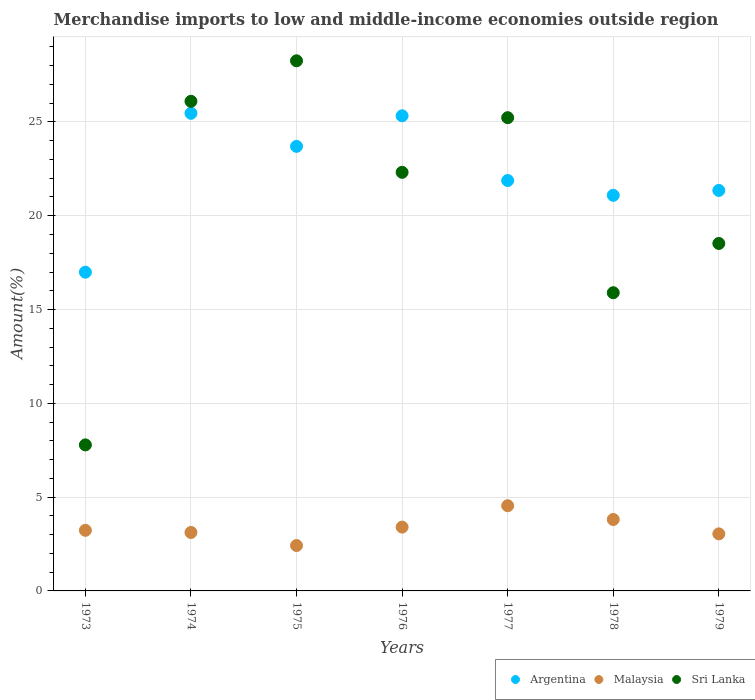How many different coloured dotlines are there?
Give a very brief answer. 3. Is the number of dotlines equal to the number of legend labels?
Offer a very short reply. Yes. What is the percentage of amount earned from merchandise imports in Malaysia in 1978?
Your answer should be very brief. 3.81. Across all years, what is the maximum percentage of amount earned from merchandise imports in Argentina?
Give a very brief answer. 25.46. Across all years, what is the minimum percentage of amount earned from merchandise imports in Sri Lanka?
Offer a terse response. 7.78. In which year was the percentage of amount earned from merchandise imports in Argentina maximum?
Provide a succinct answer. 1974. In which year was the percentage of amount earned from merchandise imports in Sri Lanka minimum?
Keep it short and to the point. 1973. What is the total percentage of amount earned from merchandise imports in Sri Lanka in the graph?
Give a very brief answer. 144.1. What is the difference between the percentage of amount earned from merchandise imports in Sri Lanka in 1974 and that in 1976?
Ensure brevity in your answer.  3.79. What is the difference between the percentage of amount earned from merchandise imports in Argentina in 1975 and the percentage of amount earned from merchandise imports in Sri Lanka in 1974?
Provide a short and direct response. -2.4. What is the average percentage of amount earned from merchandise imports in Malaysia per year?
Give a very brief answer. 3.37. In the year 1976, what is the difference between the percentage of amount earned from merchandise imports in Sri Lanka and percentage of amount earned from merchandise imports in Malaysia?
Provide a short and direct response. 18.91. What is the ratio of the percentage of amount earned from merchandise imports in Sri Lanka in 1978 to that in 1979?
Your answer should be compact. 0.86. Is the difference between the percentage of amount earned from merchandise imports in Sri Lanka in 1974 and 1978 greater than the difference between the percentage of amount earned from merchandise imports in Malaysia in 1974 and 1978?
Offer a terse response. Yes. What is the difference between the highest and the second highest percentage of amount earned from merchandise imports in Sri Lanka?
Give a very brief answer. 2.16. What is the difference between the highest and the lowest percentage of amount earned from merchandise imports in Argentina?
Offer a very short reply. 8.47. What is the difference between two consecutive major ticks on the Y-axis?
Make the answer very short. 5. Where does the legend appear in the graph?
Your answer should be compact. Bottom right. What is the title of the graph?
Ensure brevity in your answer.  Merchandise imports to low and middle-income economies outside region. Does "Cambodia" appear as one of the legend labels in the graph?
Provide a succinct answer. No. What is the label or title of the Y-axis?
Your response must be concise. Amount(%). What is the Amount(%) of Argentina in 1973?
Provide a short and direct response. 16.99. What is the Amount(%) in Malaysia in 1973?
Provide a succinct answer. 3.23. What is the Amount(%) of Sri Lanka in 1973?
Make the answer very short. 7.78. What is the Amount(%) in Argentina in 1974?
Provide a succinct answer. 25.46. What is the Amount(%) of Malaysia in 1974?
Offer a very short reply. 3.12. What is the Amount(%) of Sri Lanka in 1974?
Give a very brief answer. 26.1. What is the Amount(%) of Argentina in 1975?
Your response must be concise. 23.7. What is the Amount(%) in Malaysia in 1975?
Offer a very short reply. 2.42. What is the Amount(%) in Sri Lanka in 1975?
Your response must be concise. 28.26. What is the Amount(%) of Argentina in 1976?
Give a very brief answer. 25.33. What is the Amount(%) in Malaysia in 1976?
Give a very brief answer. 3.4. What is the Amount(%) of Sri Lanka in 1976?
Your response must be concise. 22.31. What is the Amount(%) in Argentina in 1977?
Your answer should be very brief. 21.88. What is the Amount(%) of Malaysia in 1977?
Offer a very short reply. 4.54. What is the Amount(%) in Sri Lanka in 1977?
Offer a terse response. 25.23. What is the Amount(%) of Argentina in 1978?
Your answer should be compact. 21.09. What is the Amount(%) of Malaysia in 1978?
Provide a short and direct response. 3.81. What is the Amount(%) in Sri Lanka in 1978?
Give a very brief answer. 15.9. What is the Amount(%) of Argentina in 1979?
Offer a very short reply. 21.35. What is the Amount(%) in Malaysia in 1979?
Give a very brief answer. 3.04. What is the Amount(%) of Sri Lanka in 1979?
Provide a short and direct response. 18.52. Across all years, what is the maximum Amount(%) of Argentina?
Provide a succinct answer. 25.46. Across all years, what is the maximum Amount(%) of Malaysia?
Make the answer very short. 4.54. Across all years, what is the maximum Amount(%) of Sri Lanka?
Offer a terse response. 28.26. Across all years, what is the minimum Amount(%) of Argentina?
Give a very brief answer. 16.99. Across all years, what is the minimum Amount(%) in Malaysia?
Offer a very short reply. 2.42. Across all years, what is the minimum Amount(%) of Sri Lanka?
Give a very brief answer. 7.78. What is the total Amount(%) in Argentina in the graph?
Offer a very short reply. 155.79. What is the total Amount(%) in Malaysia in the graph?
Your answer should be compact. 23.56. What is the total Amount(%) in Sri Lanka in the graph?
Make the answer very short. 144.1. What is the difference between the Amount(%) in Argentina in 1973 and that in 1974?
Your answer should be compact. -8.47. What is the difference between the Amount(%) in Malaysia in 1973 and that in 1974?
Give a very brief answer. 0.11. What is the difference between the Amount(%) of Sri Lanka in 1973 and that in 1974?
Your answer should be very brief. -18.32. What is the difference between the Amount(%) in Argentina in 1973 and that in 1975?
Keep it short and to the point. -6.71. What is the difference between the Amount(%) in Malaysia in 1973 and that in 1975?
Keep it short and to the point. 0.81. What is the difference between the Amount(%) in Sri Lanka in 1973 and that in 1975?
Give a very brief answer. -20.47. What is the difference between the Amount(%) in Argentina in 1973 and that in 1976?
Offer a very short reply. -8.34. What is the difference between the Amount(%) of Malaysia in 1973 and that in 1976?
Your answer should be very brief. -0.17. What is the difference between the Amount(%) of Sri Lanka in 1973 and that in 1976?
Offer a very short reply. -14.53. What is the difference between the Amount(%) in Argentina in 1973 and that in 1977?
Offer a terse response. -4.89. What is the difference between the Amount(%) in Malaysia in 1973 and that in 1977?
Your answer should be very brief. -1.31. What is the difference between the Amount(%) of Sri Lanka in 1973 and that in 1977?
Make the answer very short. -17.44. What is the difference between the Amount(%) in Argentina in 1973 and that in 1978?
Your response must be concise. -4.1. What is the difference between the Amount(%) of Malaysia in 1973 and that in 1978?
Your answer should be very brief. -0.58. What is the difference between the Amount(%) of Sri Lanka in 1973 and that in 1978?
Give a very brief answer. -8.11. What is the difference between the Amount(%) in Argentina in 1973 and that in 1979?
Your answer should be compact. -4.36. What is the difference between the Amount(%) of Malaysia in 1973 and that in 1979?
Your answer should be compact. 0.19. What is the difference between the Amount(%) of Sri Lanka in 1973 and that in 1979?
Your response must be concise. -10.74. What is the difference between the Amount(%) of Argentina in 1974 and that in 1975?
Your answer should be compact. 1.76. What is the difference between the Amount(%) in Malaysia in 1974 and that in 1975?
Keep it short and to the point. 0.7. What is the difference between the Amount(%) in Sri Lanka in 1974 and that in 1975?
Your response must be concise. -2.16. What is the difference between the Amount(%) in Argentina in 1974 and that in 1976?
Your answer should be compact. 0.13. What is the difference between the Amount(%) in Malaysia in 1974 and that in 1976?
Your answer should be very brief. -0.29. What is the difference between the Amount(%) of Sri Lanka in 1974 and that in 1976?
Make the answer very short. 3.79. What is the difference between the Amount(%) of Argentina in 1974 and that in 1977?
Make the answer very short. 3.58. What is the difference between the Amount(%) of Malaysia in 1974 and that in 1977?
Offer a terse response. -1.43. What is the difference between the Amount(%) in Sri Lanka in 1974 and that in 1977?
Offer a very short reply. 0.87. What is the difference between the Amount(%) in Argentina in 1974 and that in 1978?
Keep it short and to the point. 4.37. What is the difference between the Amount(%) in Malaysia in 1974 and that in 1978?
Make the answer very short. -0.69. What is the difference between the Amount(%) of Sri Lanka in 1974 and that in 1978?
Offer a very short reply. 10.2. What is the difference between the Amount(%) in Argentina in 1974 and that in 1979?
Make the answer very short. 4.11. What is the difference between the Amount(%) of Malaysia in 1974 and that in 1979?
Provide a succinct answer. 0.07. What is the difference between the Amount(%) of Sri Lanka in 1974 and that in 1979?
Provide a succinct answer. 7.58. What is the difference between the Amount(%) in Argentina in 1975 and that in 1976?
Ensure brevity in your answer.  -1.63. What is the difference between the Amount(%) in Malaysia in 1975 and that in 1976?
Keep it short and to the point. -0.98. What is the difference between the Amount(%) of Sri Lanka in 1975 and that in 1976?
Keep it short and to the point. 5.94. What is the difference between the Amount(%) of Argentina in 1975 and that in 1977?
Provide a succinct answer. 1.82. What is the difference between the Amount(%) in Malaysia in 1975 and that in 1977?
Your answer should be very brief. -2.12. What is the difference between the Amount(%) of Sri Lanka in 1975 and that in 1977?
Provide a short and direct response. 3.03. What is the difference between the Amount(%) in Argentina in 1975 and that in 1978?
Your answer should be very brief. 2.61. What is the difference between the Amount(%) in Malaysia in 1975 and that in 1978?
Ensure brevity in your answer.  -1.39. What is the difference between the Amount(%) in Sri Lanka in 1975 and that in 1978?
Your answer should be very brief. 12.36. What is the difference between the Amount(%) of Argentina in 1975 and that in 1979?
Give a very brief answer. 2.35. What is the difference between the Amount(%) of Malaysia in 1975 and that in 1979?
Your answer should be compact. -0.62. What is the difference between the Amount(%) in Sri Lanka in 1975 and that in 1979?
Make the answer very short. 9.74. What is the difference between the Amount(%) of Argentina in 1976 and that in 1977?
Provide a succinct answer. 3.45. What is the difference between the Amount(%) in Malaysia in 1976 and that in 1977?
Offer a terse response. -1.14. What is the difference between the Amount(%) in Sri Lanka in 1976 and that in 1977?
Offer a very short reply. -2.91. What is the difference between the Amount(%) of Argentina in 1976 and that in 1978?
Your response must be concise. 4.24. What is the difference between the Amount(%) in Malaysia in 1976 and that in 1978?
Ensure brevity in your answer.  -0.41. What is the difference between the Amount(%) of Sri Lanka in 1976 and that in 1978?
Your response must be concise. 6.42. What is the difference between the Amount(%) of Argentina in 1976 and that in 1979?
Ensure brevity in your answer.  3.98. What is the difference between the Amount(%) of Malaysia in 1976 and that in 1979?
Ensure brevity in your answer.  0.36. What is the difference between the Amount(%) in Sri Lanka in 1976 and that in 1979?
Your answer should be very brief. 3.79. What is the difference between the Amount(%) in Argentina in 1977 and that in 1978?
Keep it short and to the point. 0.79. What is the difference between the Amount(%) in Malaysia in 1977 and that in 1978?
Ensure brevity in your answer.  0.73. What is the difference between the Amount(%) in Sri Lanka in 1977 and that in 1978?
Make the answer very short. 9.33. What is the difference between the Amount(%) in Argentina in 1977 and that in 1979?
Provide a succinct answer. 0.53. What is the difference between the Amount(%) in Malaysia in 1977 and that in 1979?
Your answer should be compact. 1.5. What is the difference between the Amount(%) of Sri Lanka in 1977 and that in 1979?
Your response must be concise. 6.71. What is the difference between the Amount(%) of Argentina in 1978 and that in 1979?
Offer a very short reply. -0.26. What is the difference between the Amount(%) in Malaysia in 1978 and that in 1979?
Your answer should be very brief. 0.77. What is the difference between the Amount(%) in Sri Lanka in 1978 and that in 1979?
Your answer should be compact. -2.63. What is the difference between the Amount(%) of Argentina in 1973 and the Amount(%) of Malaysia in 1974?
Make the answer very short. 13.87. What is the difference between the Amount(%) of Argentina in 1973 and the Amount(%) of Sri Lanka in 1974?
Your answer should be compact. -9.11. What is the difference between the Amount(%) in Malaysia in 1973 and the Amount(%) in Sri Lanka in 1974?
Your response must be concise. -22.87. What is the difference between the Amount(%) of Argentina in 1973 and the Amount(%) of Malaysia in 1975?
Offer a very short reply. 14.57. What is the difference between the Amount(%) in Argentina in 1973 and the Amount(%) in Sri Lanka in 1975?
Make the answer very short. -11.27. What is the difference between the Amount(%) in Malaysia in 1973 and the Amount(%) in Sri Lanka in 1975?
Ensure brevity in your answer.  -25.03. What is the difference between the Amount(%) in Argentina in 1973 and the Amount(%) in Malaysia in 1976?
Provide a succinct answer. 13.59. What is the difference between the Amount(%) of Argentina in 1973 and the Amount(%) of Sri Lanka in 1976?
Offer a very short reply. -5.32. What is the difference between the Amount(%) of Malaysia in 1973 and the Amount(%) of Sri Lanka in 1976?
Your response must be concise. -19.08. What is the difference between the Amount(%) in Argentina in 1973 and the Amount(%) in Malaysia in 1977?
Provide a short and direct response. 12.45. What is the difference between the Amount(%) of Argentina in 1973 and the Amount(%) of Sri Lanka in 1977?
Your answer should be compact. -8.24. What is the difference between the Amount(%) in Malaysia in 1973 and the Amount(%) in Sri Lanka in 1977?
Offer a terse response. -22. What is the difference between the Amount(%) of Argentina in 1973 and the Amount(%) of Malaysia in 1978?
Keep it short and to the point. 13.18. What is the difference between the Amount(%) in Argentina in 1973 and the Amount(%) in Sri Lanka in 1978?
Your response must be concise. 1.09. What is the difference between the Amount(%) in Malaysia in 1973 and the Amount(%) in Sri Lanka in 1978?
Make the answer very short. -12.67. What is the difference between the Amount(%) in Argentina in 1973 and the Amount(%) in Malaysia in 1979?
Your answer should be compact. 13.95. What is the difference between the Amount(%) of Argentina in 1973 and the Amount(%) of Sri Lanka in 1979?
Your response must be concise. -1.53. What is the difference between the Amount(%) in Malaysia in 1973 and the Amount(%) in Sri Lanka in 1979?
Provide a short and direct response. -15.29. What is the difference between the Amount(%) of Argentina in 1974 and the Amount(%) of Malaysia in 1975?
Give a very brief answer. 23.04. What is the difference between the Amount(%) of Argentina in 1974 and the Amount(%) of Sri Lanka in 1975?
Keep it short and to the point. -2.8. What is the difference between the Amount(%) of Malaysia in 1974 and the Amount(%) of Sri Lanka in 1975?
Give a very brief answer. -25.14. What is the difference between the Amount(%) of Argentina in 1974 and the Amount(%) of Malaysia in 1976?
Your answer should be compact. 22.06. What is the difference between the Amount(%) of Argentina in 1974 and the Amount(%) of Sri Lanka in 1976?
Your response must be concise. 3.15. What is the difference between the Amount(%) of Malaysia in 1974 and the Amount(%) of Sri Lanka in 1976?
Offer a very short reply. -19.2. What is the difference between the Amount(%) in Argentina in 1974 and the Amount(%) in Malaysia in 1977?
Keep it short and to the point. 20.92. What is the difference between the Amount(%) in Argentina in 1974 and the Amount(%) in Sri Lanka in 1977?
Ensure brevity in your answer.  0.23. What is the difference between the Amount(%) in Malaysia in 1974 and the Amount(%) in Sri Lanka in 1977?
Provide a short and direct response. -22.11. What is the difference between the Amount(%) in Argentina in 1974 and the Amount(%) in Malaysia in 1978?
Keep it short and to the point. 21.65. What is the difference between the Amount(%) in Argentina in 1974 and the Amount(%) in Sri Lanka in 1978?
Offer a terse response. 9.56. What is the difference between the Amount(%) of Malaysia in 1974 and the Amount(%) of Sri Lanka in 1978?
Make the answer very short. -12.78. What is the difference between the Amount(%) of Argentina in 1974 and the Amount(%) of Malaysia in 1979?
Ensure brevity in your answer.  22.42. What is the difference between the Amount(%) of Argentina in 1974 and the Amount(%) of Sri Lanka in 1979?
Your answer should be very brief. 6.94. What is the difference between the Amount(%) in Malaysia in 1974 and the Amount(%) in Sri Lanka in 1979?
Your answer should be very brief. -15.41. What is the difference between the Amount(%) in Argentina in 1975 and the Amount(%) in Malaysia in 1976?
Offer a very short reply. 20.3. What is the difference between the Amount(%) of Argentina in 1975 and the Amount(%) of Sri Lanka in 1976?
Provide a short and direct response. 1.38. What is the difference between the Amount(%) in Malaysia in 1975 and the Amount(%) in Sri Lanka in 1976?
Provide a short and direct response. -19.89. What is the difference between the Amount(%) of Argentina in 1975 and the Amount(%) of Malaysia in 1977?
Give a very brief answer. 19.16. What is the difference between the Amount(%) in Argentina in 1975 and the Amount(%) in Sri Lanka in 1977?
Your answer should be compact. -1.53. What is the difference between the Amount(%) in Malaysia in 1975 and the Amount(%) in Sri Lanka in 1977?
Offer a very short reply. -22.81. What is the difference between the Amount(%) of Argentina in 1975 and the Amount(%) of Malaysia in 1978?
Your answer should be compact. 19.89. What is the difference between the Amount(%) of Argentina in 1975 and the Amount(%) of Sri Lanka in 1978?
Provide a succinct answer. 7.8. What is the difference between the Amount(%) in Malaysia in 1975 and the Amount(%) in Sri Lanka in 1978?
Provide a succinct answer. -13.48. What is the difference between the Amount(%) of Argentina in 1975 and the Amount(%) of Malaysia in 1979?
Your response must be concise. 20.66. What is the difference between the Amount(%) in Argentina in 1975 and the Amount(%) in Sri Lanka in 1979?
Give a very brief answer. 5.18. What is the difference between the Amount(%) of Malaysia in 1975 and the Amount(%) of Sri Lanka in 1979?
Keep it short and to the point. -16.1. What is the difference between the Amount(%) of Argentina in 1976 and the Amount(%) of Malaysia in 1977?
Provide a succinct answer. 20.79. What is the difference between the Amount(%) in Argentina in 1976 and the Amount(%) in Sri Lanka in 1977?
Offer a terse response. 0.1. What is the difference between the Amount(%) of Malaysia in 1976 and the Amount(%) of Sri Lanka in 1977?
Offer a very short reply. -21.82. What is the difference between the Amount(%) in Argentina in 1976 and the Amount(%) in Malaysia in 1978?
Give a very brief answer. 21.52. What is the difference between the Amount(%) in Argentina in 1976 and the Amount(%) in Sri Lanka in 1978?
Provide a succinct answer. 9.43. What is the difference between the Amount(%) in Malaysia in 1976 and the Amount(%) in Sri Lanka in 1978?
Offer a very short reply. -12.49. What is the difference between the Amount(%) in Argentina in 1976 and the Amount(%) in Malaysia in 1979?
Keep it short and to the point. 22.29. What is the difference between the Amount(%) in Argentina in 1976 and the Amount(%) in Sri Lanka in 1979?
Keep it short and to the point. 6.81. What is the difference between the Amount(%) in Malaysia in 1976 and the Amount(%) in Sri Lanka in 1979?
Provide a short and direct response. -15.12. What is the difference between the Amount(%) in Argentina in 1977 and the Amount(%) in Malaysia in 1978?
Keep it short and to the point. 18.07. What is the difference between the Amount(%) of Argentina in 1977 and the Amount(%) of Sri Lanka in 1978?
Offer a terse response. 5.98. What is the difference between the Amount(%) of Malaysia in 1977 and the Amount(%) of Sri Lanka in 1978?
Offer a very short reply. -11.35. What is the difference between the Amount(%) in Argentina in 1977 and the Amount(%) in Malaysia in 1979?
Provide a succinct answer. 18.83. What is the difference between the Amount(%) in Argentina in 1977 and the Amount(%) in Sri Lanka in 1979?
Your answer should be compact. 3.35. What is the difference between the Amount(%) in Malaysia in 1977 and the Amount(%) in Sri Lanka in 1979?
Provide a succinct answer. -13.98. What is the difference between the Amount(%) of Argentina in 1978 and the Amount(%) of Malaysia in 1979?
Your answer should be very brief. 18.05. What is the difference between the Amount(%) of Argentina in 1978 and the Amount(%) of Sri Lanka in 1979?
Your response must be concise. 2.57. What is the difference between the Amount(%) in Malaysia in 1978 and the Amount(%) in Sri Lanka in 1979?
Provide a short and direct response. -14.71. What is the average Amount(%) in Argentina per year?
Offer a very short reply. 22.26. What is the average Amount(%) in Malaysia per year?
Ensure brevity in your answer.  3.37. What is the average Amount(%) of Sri Lanka per year?
Give a very brief answer. 20.59. In the year 1973, what is the difference between the Amount(%) in Argentina and Amount(%) in Malaysia?
Offer a terse response. 13.76. In the year 1973, what is the difference between the Amount(%) of Argentina and Amount(%) of Sri Lanka?
Keep it short and to the point. 9.21. In the year 1973, what is the difference between the Amount(%) in Malaysia and Amount(%) in Sri Lanka?
Keep it short and to the point. -4.55. In the year 1974, what is the difference between the Amount(%) of Argentina and Amount(%) of Malaysia?
Ensure brevity in your answer.  22.34. In the year 1974, what is the difference between the Amount(%) in Argentina and Amount(%) in Sri Lanka?
Give a very brief answer. -0.64. In the year 1974, what is the difference between the Amount(%) in Malaysia and Amount(%) in Sri Lanka?
Your answer should be very brief. -22.98. In the year 1975, what is the difference between the Amount(%) of Argentina and Amount(%) of Malaysia?
Your answer should be compact. 21.28. In the year 1975, what is the difference between the Amount(%) in Argentina and Amount(%) in Sri Lanka?
Offer a terse response. -4.56. In the year 1975, what is the difference between the Amount(%) in Malaysia and Amount(%) in Sri Lanka?
Your answer should be compact. -25.84. In the year 1976, what is the difference between the Amount(%) in Argentina and Amount(%) in Malaysia?
Offer a very short reply. 21.93. In the year 1976, what is the difference between the Amount(%) of Argentina and Amount(%) of Sri Lanka?
Keep it short and to the point. 3.01. In the year 1976, what is the difference between the Amount(%) in Malaysia and Amount(%) in Sri Lanka?
Offer a very short reply. -18.91. In the year 1977, what is the difference between the Amount(%) in Argentina and Amount(%) in Malaysia?
Your answer should be very brief. 17.33. In the year 1977, what is the difference between the Amount(%) of Argentina and Amount(%) of Sri Lanka?
Offer a very short reply. -3.35. In the year 1977, what is the difference between the Amount(%) in Malaysia and Amount(%) in Sri Lanka?
Ensure brevity in your answer.  -20.69. In the year 1978, what is the difference between the Amount(%) in Argentina and Amount(%) in Malaysia?
Offer a very short reply. 17.28. In the year 1978, what is the difference between the Amount(%) of Argentina and Amount(%) of Sri Lanka?
Ensure brevity in your answer.  5.19. In the year 1978, what is the difference between the Amount(%) in Malaysia and Amount(%) in Sri Lanka?
Provide a succinct answer. -12.09. In the year 1979, what is the difference between the Amount(%) of Argentina and Amount(%) of Malaysia?
Your answer should be compact. 18.31. In the year 1979, what is the difference between the Amount(%) of Argentina and Amount(%) of Sri Lanka?
Ensure brevity in your answer.  2.83. In the year 1979, what is the difference between the Amount(%) of Malaysia and Amount(%) of Sri Lanka?
Give a very brief answer. -15.48. What is the ratio of the Amount(%) in Argentina in 1973 to that in 1974?
Provide a succinct answer. 0.67. What is the ratio of the Amount(%) in Malaysia in 1973 to that in 1974?
Keep it short and to the point. 1.04. What is the ratio of the Amount(%) in Sri Lanka in 1973 to that in 1974?
Ensure brevity in your answer.  0.3. What is the ratio of the Amount(%) of Argentina in 1973 to that in 1975?
Your answer should be very brief. 0.72. What is the ratio of the Amount(%) of Malaysia in 1973 to that in 1975?
Your answer should be compact. 1.33. What is the ratio of the Amount(%) in Sri Lanka in 1973 to that in 1975?
Your response must be concise. 0.28. What is the ratio of the Amount(%) in Argentina in 1973 to that in 1976?
Your answer should be very brief. 0.67. What is the ratio of the Amount(%) of Malaysia in 1973 to that in 1976?
Your response must be concise. 0.95. What is the ratio of the Amount(%) in Sri Lanka in 1973 to that in 1976?
Give a very brief answer. 0.35. What is the ratio of the Amount(%) of Argentina in 1973 to that in 1977?
Provide a succinct answer. 0.78. What is the ratio of the Amount(%) of Malaysia in 1973 to that in 1977?
Offer a terse response. 0.71. What is the ratio of the Amount(%) of Sri Lanka in 1973 to that in 1977?
Your answer should be very brief. 0.31. What is the ratio of the Amount(%) of Argentina in 1973 to that in 1978?
Your response must be concise. 0.81. What is the ratio of the Amount(%) in Malaysia in 1973 to that in 1978?
Your response must be concise. 0.85. What is the ratio of the Amount(%) in Sri Lanka in 1973 to that in 1978?
Your response must be concise. 0.49. What is the ratio of the Amount(%) in Argentina in 1973 to that in 1979?
Your answer should be compact. 0.8. What is the ratio of the Amount(%) of Malaysia in 1973 to that in 1979?
Give a very brief answer. 1.06. What is the ratio of the Amount(%) of Sri Lanka in 1973 to that in 1979?
Your response must be concise. 0.42. What is the ratio of the Amount(%) in Argentina in 1974 to that in 1975?
Make the answer very short. 1.07. What is the ratio of the Amount(%) in Malaysia in 1974 to that in 1975?
Your answer should be very brief. 1.29. What is the ratio of the Amount(%) in Sri Lanka in 1974 to that in 1975?
Provide a succinct answer. 0.92. What is the ratio of the Amount(%) in Malaysia in 1974 to that in 1976?
Provide a short and direct response. 0.92. What is the ratio of the Amount(%) in Sri Lanka in 1974 to that in 1976?
Provide a short and direct response. 1.17. What is the ratio of the Amount(%) in Argentina in 1974 to that in 1977?
Offer a terse response. 1.16. What is the ratio of the Amount(%) of Malaysia in 1974 to that in 1977?
Your response must be concise. 0.69. What is the ratio of the Amount(%) in Sri Lanka in 1974 to that in 1977?
Ensure brevity in your answer.  1.03. What is the ratio of the Amount(%) in Argentina in 1974 to that in 1978?
Offer a terse response. 1.21. What is the ratio of the Amount(%) of Malaysia in 1974 to that in 1978?
Ensure brevity in your answer.  0.82. What is the ratio of the Amount(%) in Sri Lanka in 1974 to that in 1978?
Your response must be concise. 1.64. What is the ratio of the Amount(%) of Argentina in 1974 to that in 1979?
Provide a succinct answer. 1.19. What is the ratio of the Amount(%) in Malaysia in 1974 to that in 1979?
Your answer should be very brief. 1.02. What is the ratio of the Amount(%) in Sri Lanka in 1974 to that in 1979?
Provide a succinct answer. 1.41. What is the ratio of the Amount(%) in Argentina in 1975 to that in 1976?
Your response must be concise. 0.94. What is the ratio of the Amount(%) in Malaysia in 1975 to that in 1976?
Make the answer very short. 0.71. What is the ratio of the Amount(%) in Sri Lanka in 1975 to that in 1976?
Make the answer very short. 1.27. What is the ratio of the Amount(%) in Argentina in 1975 to that in 1977?
Provide a succinct answer. 1.08. What is the ratio of the Amount(%) of Malaysia in 1975 to that in 1977?
Offer a terse response. 0.53. What is the ratio of the Amount(%) in Sri Lanka in 1975 to that in 1977?
Make the answer very short. 1.12. What is the ratio of the Amount(%) of Argentina in 1975 to that in 1978?
Offer a terse response. 1.12. What is the ratio of the Amount(%) of Malaysia in 1975 to that in 1978?
Your answer should be very brief. 0.64. What is the ratio of the Amount(%) of Sri Lanka in 1975 to that in 1978?
Your response must be concise. 1.78. What is the ratio of the Amount(%) of Argentina in 1975 to that in 1979?
Your answer should be very brief. 1.11. What is the ratio of the Amount(%) of Malaysia in 1975 to that in 1979?
Provide a succinct answer. 0.8. What is the ratio of the Amount(%) in Sri Lanka in 1975 to that in 1979?
Ensure brevity in your answer.  1.53. What is the ratio of the Amount(%) of Argentina in 1976 to that in 1977?
Your answer should be very brief. 1.16. What is the ratio of the Amount(%) in Malaysia in 1976 to that in 1977?
Your response must be concise. 0.75. What is the ratio of the Amount(%) of Sri Lanka in 1976 to that in 1977?
Provide a short and direct response. 0.88. What is the ratio of the Amount(%) in Argentina in 1976 to that in 1978?
Your answer should be compact. 1.2. What is the ratio of the Amount(%) in Malaysia in 1976 to that in 1978?
Provide a succinct answer. 0.89. What is the ratio of the Amount(%) of Sri Lanka in 1976 to that in 1978?
Your answer should be compact. 1.4. What is the ratio of the Amount(%) of Argentina in 1976 to that in 1979?
Give a very brief answer. 1.19. What is the ratio of the Amount(%) of Malaysia in 1976 to that in 1979?
Give a very brief answer. 1.12. What is the ratio of the Amount(%) in Sri Lanka in 1976 to that in 1979?
Give a very brief answer. 1.2. What is the ratio of the Amount(%) in Argentina in 1977 to that in 1978?
Offer a very short reply. 1.04. What is the ratio of the Amount(%) of Malaysia in 1977 to that in 1978?
Ensure brevity in your answer.  1.19. What is the ratio of the Amount(%) in Sri Lanka in 1977 to that in 1978?
Offer a terse response. 1.59. What is the ratio of the Amount(%) of Argentina in 1977 to that in 1979?
Provide a succinct answer. 1.02. What is the ratio of the Amount(%) of Malaysia in 1977 to that in 1979?
Make the answer very short. 1.49. What is the ratio of the Amount(%) of Sri Lanka in 1977 to that in 1979?
Your response must be concise. 1.36. What is the ratio of the Amount(%) of Argentina in 1978 to that in 1979?
Your answer should be compact. 0.99. What is the ratio of the Amount(%) in Malaysia in 1978 to that in 1979?
Provide a succinct answer. 1.25. What is the ratio of the Amount(%) of Sri Lanka in 1978 to that in 1979?
Give a very brief answer. 0.86. What is the difference between the highest and the second highest Amount(%) of Argentina?
Keep it short and to the point. 0.13. What is the difference between the highest and the second highest Amount(%) of Malaysia?
Provide a short and direct response. 0.73. What is the difference between the highest and the second highest Amount(%) in Sri Lanka?
Make the answer very short. 2.16. What is the difference between the highest and the lowest Amount(%) of Argentina?
Offer a terse response. 8.47. What is the difference between the highest and the lowest Amount(%) of Malaysia?
Keep it short and to the point. 2.12. What is the difference between the highest and the lowest Amount(%) of Sri Lanka?
Provide a short and direct response. 20.47. 